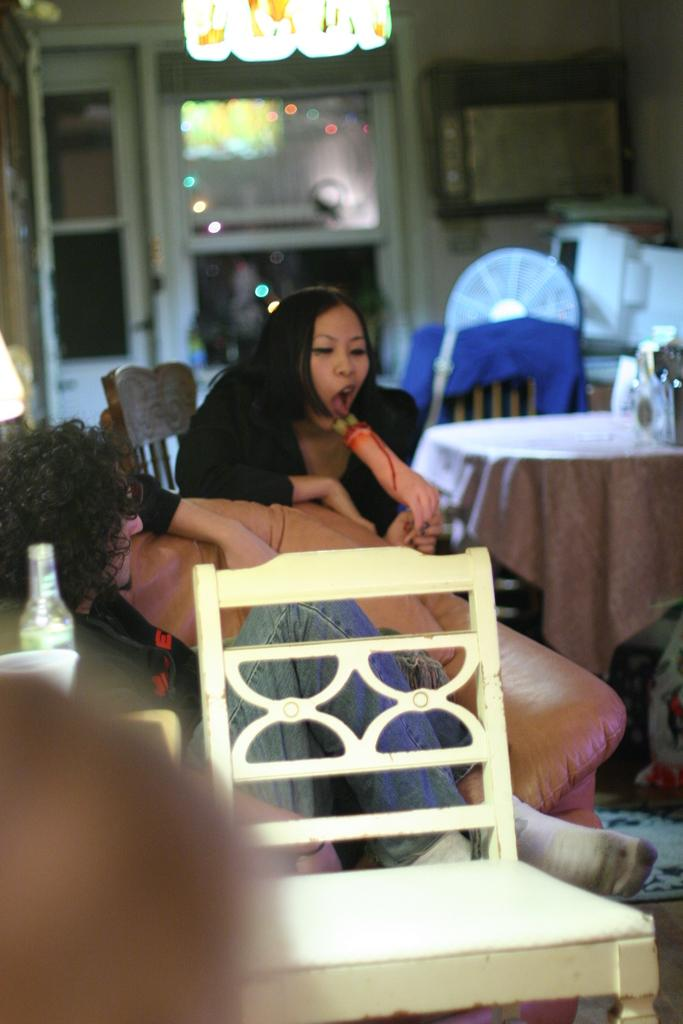What are the people in the image doing? The people in the image are sitting. What furniture is present in the image? There are chairs and a table in the image. What electronic device can be seen in the background of the image? There is a monitor visible in the background of the image. What type of shop can be seen in the image? There is no shop present in the image. 